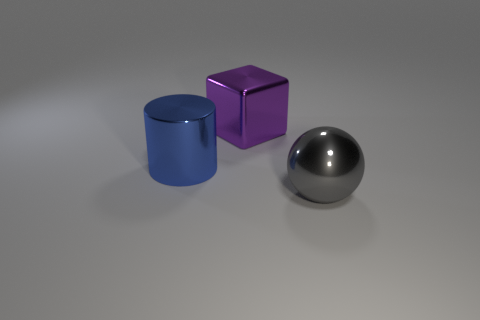What is the color of the big sphere that is made of the same material as the big block?
Your answer should be compact. Gray. What shape is the object that is in front of the purple shiny block and on the right side of the big cylinder?
Keep it short and to the point. Sphere. Are there any cylinders that have the same material as the large purple object?
Provide a succinct answer. Yes. Is the number of large balls greater than the number of red shiny objects?
Keep it short and to the point. Yes. There is a big metal thing to the right of the shiny object behind the large blue metallic cylinder in front of the big purple thing; what is its color?
Give a very brief answer. Gray. There is a shiny object that is behind the shiny cylinder; does it have the same color as the big thing in front of the large blue object?
Your answer should be very brief. No. There is a big object that is to the left of the big block; how many big metallic cylinders are right of it?
Give a very brief answer. 0. Is there a small gray metal thing?
Offer a terse response. No. What number of other things are the same color as the cube?
Give a very brief answer. 0. Are there fewer purple cubes than big gray cylinders?
Offer a terse response. No. 